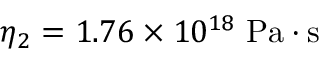<formula> <loc_0><loc_0><loc_500><loc_500>\eta _ { 2 } = 1 . 7 6 \times 1 0 ^ { 1 8 } \, P a \cdot s</formula> 